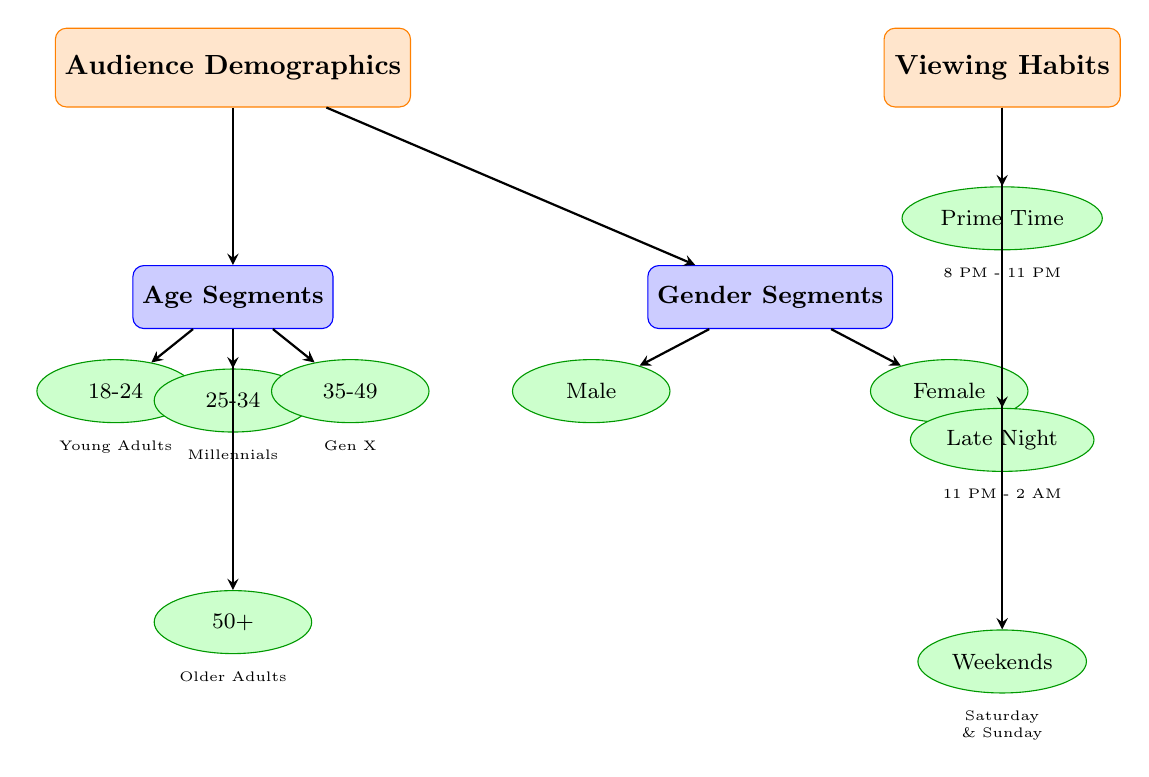What are the two main categories shown in the diagram? The diagram has two main categories: "Audience Demographics" and "Viewing Habits," indicated at the top and represented as distinct nodes.
Answer: Audience Demographics, Viewing Habits How many age segments are represented in the diagram? The age segments are shown as four distinct nodes (18-24, 25-34, 35-49, 50+) under the "Age Segments" subcategory. Therefore, there are four segments represented.
Answer: 4 What are the viewing habits listed in the diagram? The viewing habits are shown under the "Viewing Habits" category and include three segments: "Prime Time," "Late Night," and "Weekends."
Answer: Prime Time, Late Night, Weekends Which age segment is categorized as "Older Adults"? The "Older Adults" category is related to the age segment labeled "50+," which is indicated at the bottom of the age segments section.
Answer: 50+ How many gender segments are there in the diagram? The gender segments consist of two distinct nodes: "Male" and "Female," indicating that there are two gender segments in the diagram.
Answer: 2 Which age segment is associated with "Millennials"? The "Millennials" label corresponds to the age segment represented by "25-34," as indicated in the diagram under the Age Segments.
Answer: 25-34 What time frame does "Prime Time" refer to in the diagram? The "Prime Time" viewing habit is specified as "8 PM - 11 PM," which is noted in the labels beneath the corresponding node in the viewing habits section.
Answer: 8 PM - 11 PM What is the relationship between "Age Segments" and "Gender Segments"? The diagram indicates a relationship where both "Age Segments" and "Gender Segments" branch out from "Audience Demographics," showing they are both subcategories under this main category.
Answer: Audience Demographics Which age segment appears immediately below "Young Adults"? "Young Adults" corresponds to the age segment labeled "18-24," which is positioned directly beneath it in the age segments section.
Answer: 18-24 